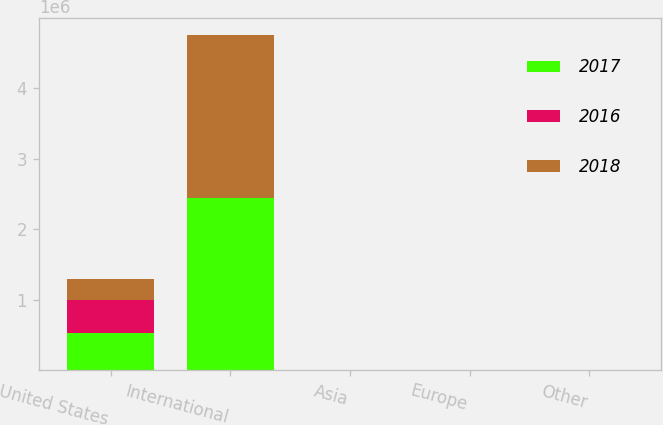<chart> <loc_0><loc_0><loc_500><loc_500><stacked_bar_chart><ecel><fcel>United States<fcel>International<fcel>Asia<fcel>Europe<fcel>Other<nl><fcel>2017<fcel>524472<fcel>2.44906e+06<fcel>78<fcel>3<fcel>1<nl><fcel>2016<fcel>467031<fcel>79.5<fcel>81<fcel>3<fcel>1<nl><fcel>2018<fcel>306328<fcel>2.3044e+06<fcel>83<fcel>4<fcel>1<nl></chart> 